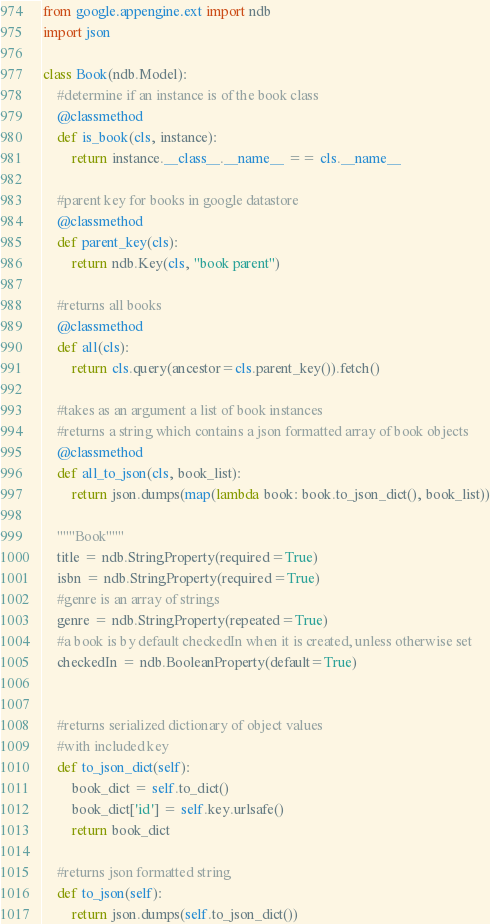<code> <loc_0><loc_0><loc_500><loc_500><_Python_>from google.appengine.ext import ndb
import json

class Book(ndb.Model): 
	#determine if an instance is of the book class
	@classmethod
	def is_book(cls, instance):
		return instance.__class__.__name__ == cls.__name__

	#parent key for books in google datastore
	@classmethod
	def parent_key(cls):
		return ndb.Key(cls, "book parent")

	#returns all books
	@classmethod
	def all(cls):
		return cls.query(ancestor=cls.parent_key()).fetch()

	#takes as an argument a list of book instances
	#returns a string which contains a json formatted array of book objects
	@classmethod
	def all_to_json(cls, book_list):
		return json.dumps(map(lambda book: book.to_json_dict(), book_list))
	
	"""Book"""
	title = ndb.StringProperty(required=True)
	isbn = ndb.StringProperty(required=True)
	#genre is an array of strings
	genre = ndb.StringProperty(repeated=True)
	#a book is by default checkedIn when it is created, unless otherwise set
	checkedIn = ndb.BooleanProperty(default=True)


	#returns serialized dictionary of object values
	#with included key
	def to_json_dict(self):
		book_dict = self.to_dict()
		book_dict['id'] = self.key.urlsafe()
		return book_dict

	#returns json formatted string
	def to_json(self):
		return json.dumps(self.to_json_dict())</code> 